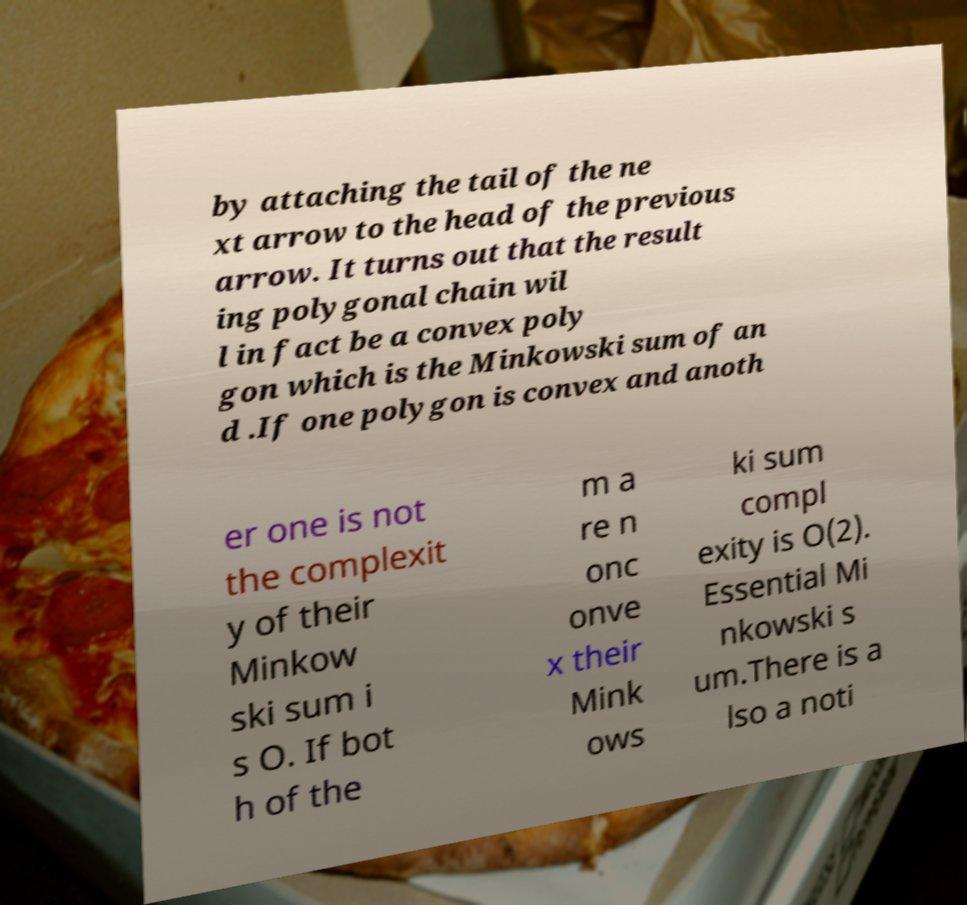Please identify and transcribe the text found in this image. by attaching the tail of the ne xt arrow to the head of the previous arrow. It turns out that the result ing polygonal chain wil l in fact be a convex poly gon which is the Minkowski sum of an d .If one polygon is convex and anoth er one is not the complexit y of their Minkow ski sum i s O. If bot h of the m a re n onc onve x their Mink ows ki sum compl exity is O(2). Essential Mi nkowski s um.There is a lso a noti 